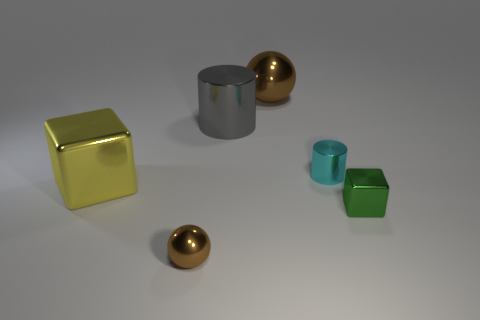Is the yellow metallic thing the same shape as the small cyan thing?
Keep it short and to the point. No. How big is the green cube?
Your answer should be very brief. Small. What number of metallic balls have the same size as the green block?
Provide a succinct answer. 1. There is a brown thing that is in front of the tiny green metallic thing; is it the same size as the metal block on the left side of the small ball?
Offer a terse response. No. The green thing that is right of the small cylinder has what shape?
Your answer should be very brief. Cube. The brown ball that is behind the big yellow metal object to the left of the small green metallic thing is made of what material?
Ensure brevity in your answer.  Metal. Is there a big metal thing of the same color as the tiny sphere?
Make the answer very short. Yes. Is the size of the gray metallic cylinder the same as the shiny block in front of the yellow shiny block?
Give a very brief answer. No. There is a metallic sphere behind the small metallic thing that is on the left side of the large metallic cylinder; how many tiny green shiny blocks are on the left side of it?
Provide a short and direct response. 0. How many metal things are behind the gray metallic cylinder?
Your answer should be compact. 1. 